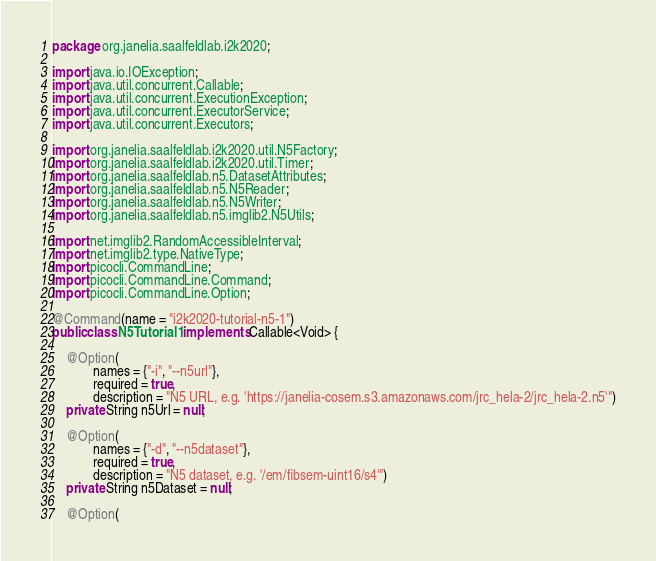Convert code to text. <code><loc_0><loc_0><loc_500><loc_500><_Java_>package org.janelia.saalfeldlab.i2k2020;

import java.io.IOException;
import java.util.concurrent.Callable;
import java.util.concurrent.ExecutionException;
import java.util.concurrent.ExecutorService;
import java.util.concurrent.Executors;

import org.janelia.saalfeldlab.i2k2020.util.N5Factory;
import org.janelia.saalfeldlab.i2k2020.util.Timer;
import org.janelia.saalfeldlab.n5.DatasetAttributes;
import org.janelia.saalfeldlab.n5.N5Reader;
import org.janelia.saalfeldlab.n5.N5Writer;
import org.janelia.saalfeldlab.n5.imglib2.N5Utils;

import net.imglib2.RandomAccessibleInterval;
import net.imglib2.type.NativeType;
import picocli.CommandLine;
import picocli.CommandLine.Command;
import picocli.CommandLine.Option;

@Command(name = "i2k2020-tutorial-n5-1")
public class N5Tutorial1 implements Callable<Void> {

	@Option(
			names = {"-i", "--n5url"},
			required = true,
			description = "N5 URL, e.g. 'https://janelia-cosem.s3.amazonaws.com/jrc_hela-2/jrc_hela-2.n5'")
	private String n5Url = null;

	@Option(
			names = {"-d", "--n5dataset"},
			required = true,
			description = "N5 dataset, e.g. '/em/fibsem-uint16/s4'")
	private String n5Dataset = null;

	@Option(</code> 